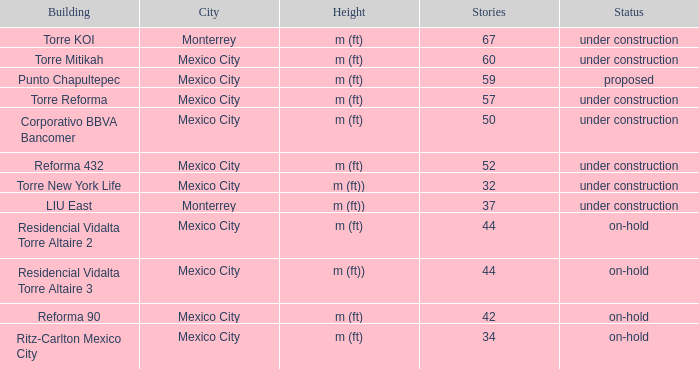How high does the 52-story building stand? M (ft). 